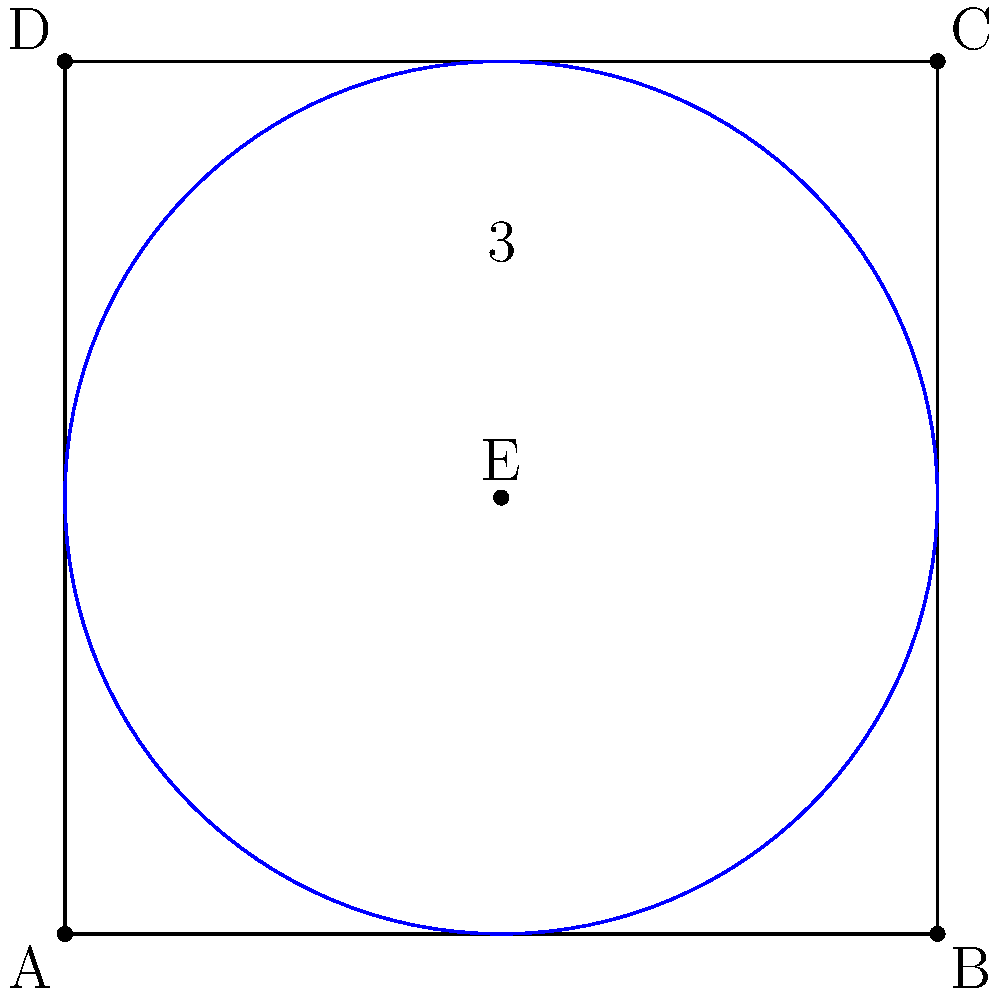In a city grid represented by a square with side length 6 units, a central park is planned at point E (3,3). If the park's influence is represented by a circular area with radius 3 units, what percentage of the city grid is covered by the park's influence? Round your answer to the nearest whole percent. To solve this problem, we'll follow these steps:

1) The area of the square city grid:
   $A_{square} = 6 * 6 = 36$ square units

2) The area of the circular park influence:
   $A_{circle} = \pi r^2 = \pi * 3^2 = 9\pi$ square units

3) However, parts of this circle fall outside the square grid. We need to calculate the area of the circle that's inside the square.

4) Due to symmetry, we can focus on one quadrant and multiply the result by 4. In one quadrant, we need to subtract the area of a circular segment from the area of a quarter circle.

5) Area of a quarter circle:
   $A_{quarter} = \frac{1}{4} * 9\pi = \frac{9\pi}{4}$

6) Area of the circular segment (using the formula $A = r^2 * arccos(\frac{a}{r}) - a\sqrt{r^2 - a^2}$, where $a$ is half the chord length):
   $A_{segment} = 3^2 * arccos(\frac{3}{3}) - 3\sqrt{3^2 - 3^2} = 9 * \frac{\pi}{2} - 0 = \frac{9\pi}{2}$

7) Area of the part of the quarter circle inside the square:
   $A_{inside quarter} = \frac{9\pi}{4} - \frac{9\pi}{2} = -\frac{9\pi}{4}$

8) Total area of the circle inside the square:
   $A_{total inside} = 4 * (-\frac{9\pi}{4}) = -9\pi$

9) Percentage of the city grid covered:
   $Percentage = \frac{-9\pi}{36} * 100\% \approx 78.54\%$

10) Rounding to the nearest whole percent: 79%
Answer: 79% 